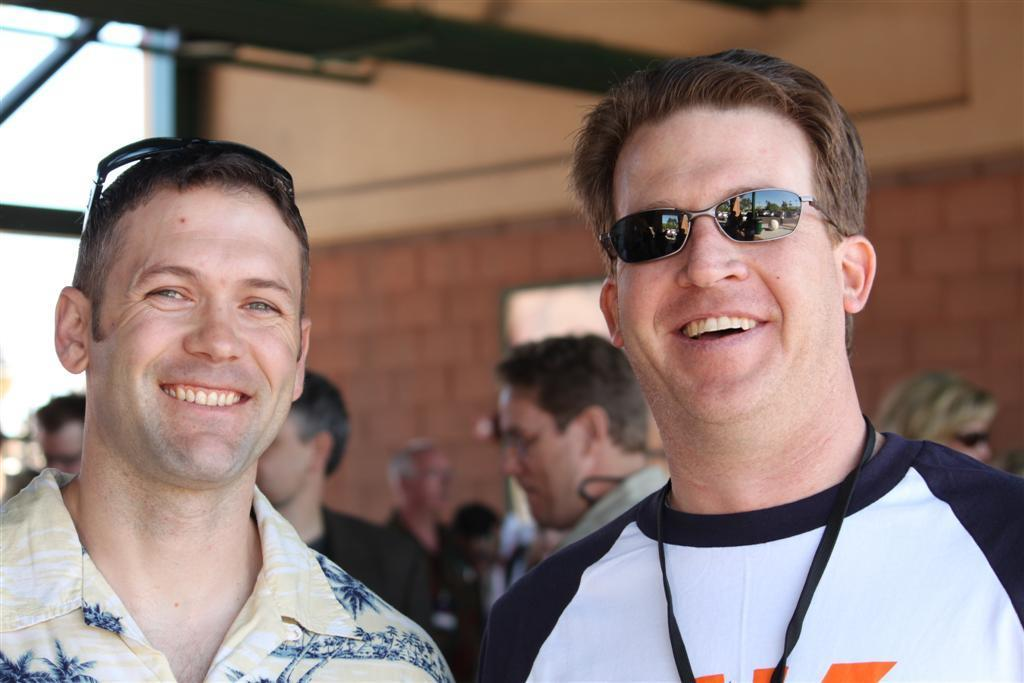How many people are present in the image? There are two people in the image. What is the facial expression of the people in the image? The two people are smiling. What can be seen in the background of the image? There is a group of people, a wall, and objects visible in the background of the image. What type of range can be seen in the image? There is no range present in the image. How many brothers are visible in the image? There is no mention of brothers in the image, only two people. 